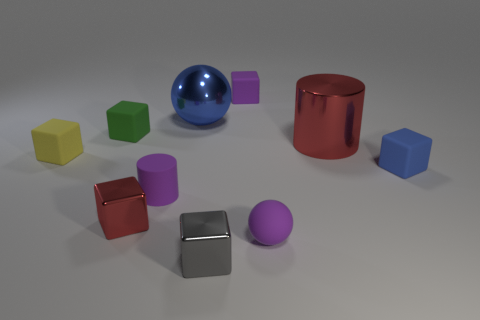Subtract all tiny purple blocks. How many blocks are left? 5 Subtract 4 cubes. How many cubes are left? 2 Subtract all green cubes. How many cubes are left? 5 Subtract all cylinders. How many objects are left? 8 Subtract all brown cubes. Subtract all yellow cylinders. How many cubes are left? 6 Add 5 purple metal cylinders. How many purple metal cylinders exist? 5 Subtract 1 red cylinders. How many objects are left? 9 Subtract all spheres. Subtract all tiny green blocks. How many objects are left? 7 Add 8 tiny cylinders. How many tiny cylinders are left? 9 